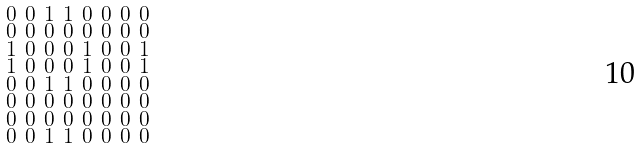Convert formula to latex. <formula><loc_0><loc_0><loc_500><loc_500>\begin{smallmatrix} 0 & 0 & 1 & 1 & 0 & 0 & 0 & 0 \\ 0 & 0 & 0 & 0 & 0 & 0 & 0 & 0 \\ 1 & 0 & 0 & 0 & 1 & 0 & 0 & 1 \\ 1 & 0 & 0 & 0 & 1 & 0 & 0 & 1 \\ 0 & 0 & 1 & 1 & 0 & 0 & 0 & 0 \\ 0 & 0 & 0 & 0 & 0 & 0 & 0 & 0 \\ 0 & 0 & 0 & 0 & 0 & 0 & 0 & 0 \\ 0 & 0 & 1 & 1 & 0 & 0 & 0 & 0 \end{smallmatrix}</formula> 